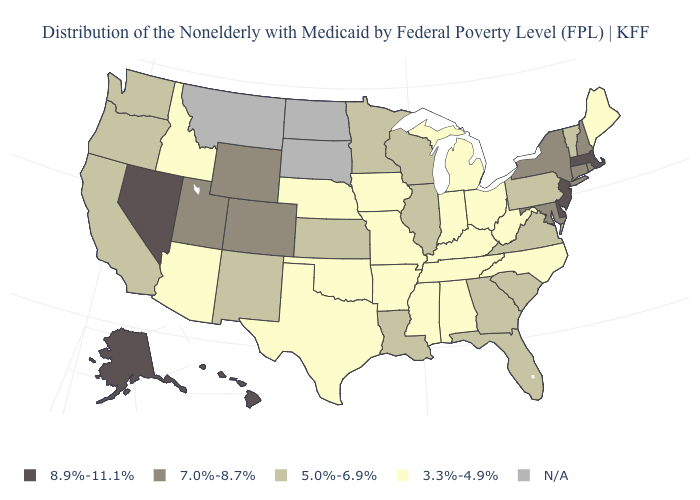What is the lowest value in the USA?
Concise answer only. 3.3%-4.9%. How many symbols are there in the legend?
Keep it brief. 5. What is the value of Wisconsin?
Give a very brief answer. 5.0%-6.9%. What is the value of Colorado?
Concise answer only. 7.0%-8.7%. What is the value of Connecticut?
Be succinct. 7.0%-8.7%. Name the states that have a value in the range 7.0%-8.7%?
Keep it brief. Colorado, Connecticut, Maryland, New Hampshire, New York, Rhode Island, Utah, Wyoming. How many symbols are there in the legend?
Concise answer only. 5. Which states have the lowest value in the USA?
Write a very short answer. Alabama, Arizona, Arkansas, Idaho, Indiana, Iowa, Kentucky, Maine, Michigan, Mississippi, Missouri, Nebraska, North Carolina, Ohio, Oklahoma, Tennessee, Texas, West Virginia. Among the states that border New York , which have the lowest value?
Write a very short answer. Pennsylvania, Vermont. What is the value of Maine?
Short answer required. 3.3%-4.9%. Among the states that border North Dakota , which have the lowest value?
Be succinct. Minnesota. What is the value of New Hampshire?
Answer briefly. 7.0%-8.7%. What is the value of Connecticut?
Be succinct. 7.0%-8.7%. 